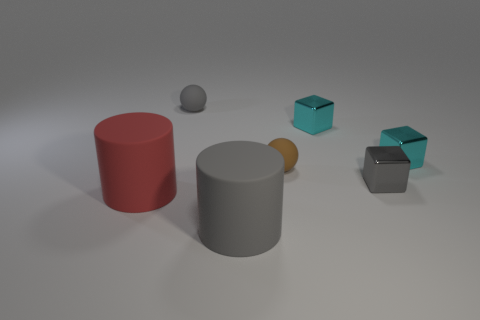Subtract all cyan cubes. How many cubes are left? 1 Subtract all gray balls. How many brown cubes are left? 0 Add 1 gray cylinders. How many objects exist? 8 Subtract all gray blocks. How many blocks are left? 2 Subtract 2 cylinders. How many cylinders are left? 0 Subtract all cubes. How many objects are left? 4 Add 1 big cylinders. How many big cylinders are left? 3 Add 3 cylinders. How many cylinders exist? 5 Subtract 0 cyan balls. How many objects are left? 7 Subtract all blue spheres. Subtract all cyan cubes. How many spheres are left? 2 